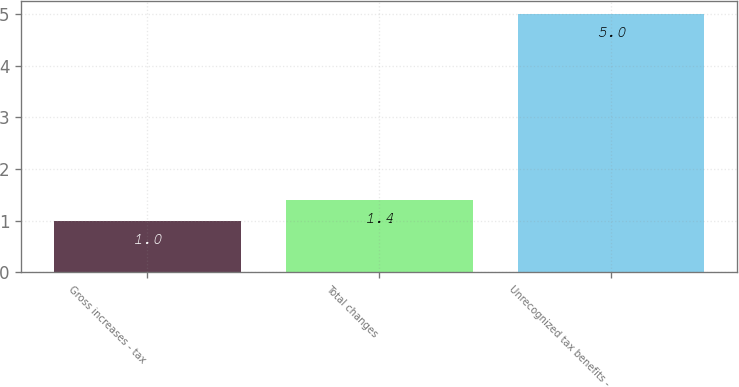<chart> <loc_0><loc_0><loc_500><loc_500><bar_chart><fcel>Gross increases - tax<fcel>Total changes<fcel>Unrecognized tax benefits -<nl><fcel>1<fcel>1.4<fcel>5<nl></chart> 